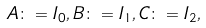Convert formula to latex. <formula><loc_0><loc_0><loc_500><loc_500>A \colon = I _ { 0 } , B \colon = I _ { 1 } , C \colon = I _ { 2 } ,</formula> 